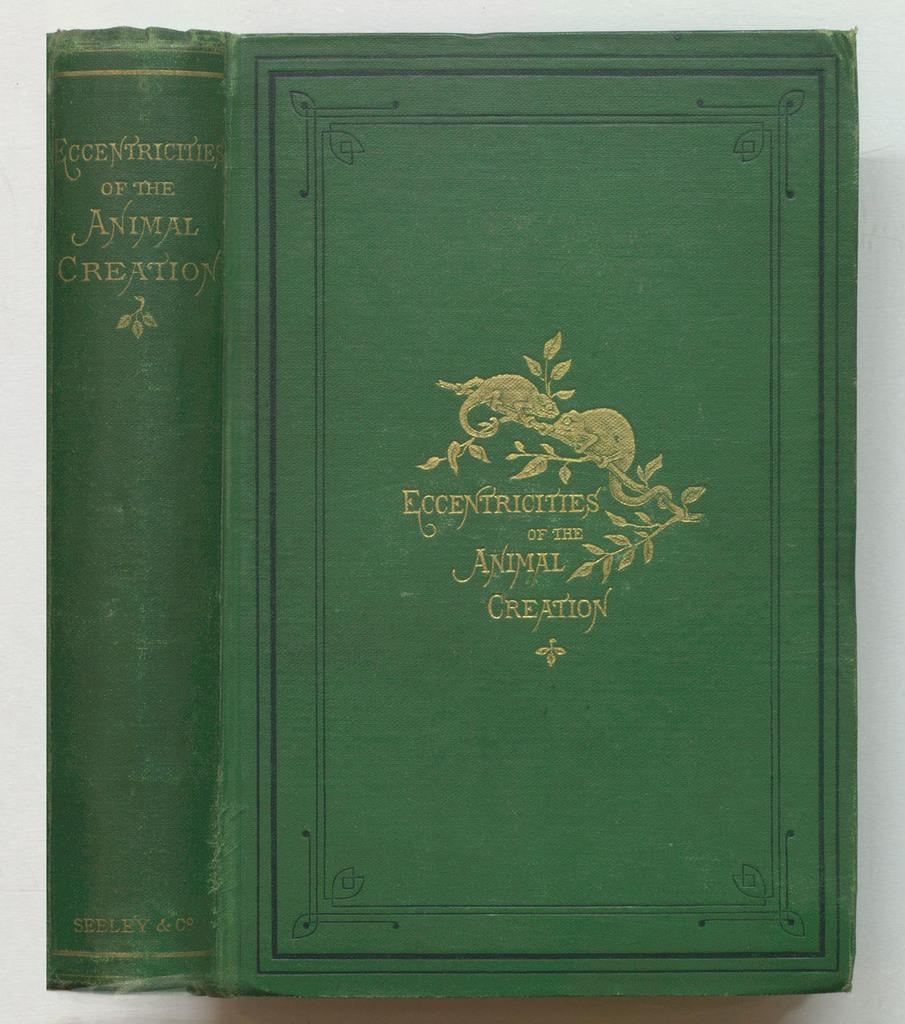<image>
Render a clear and concise summary of the photo. An old green book about specific eccentricities is published by Seeley. 